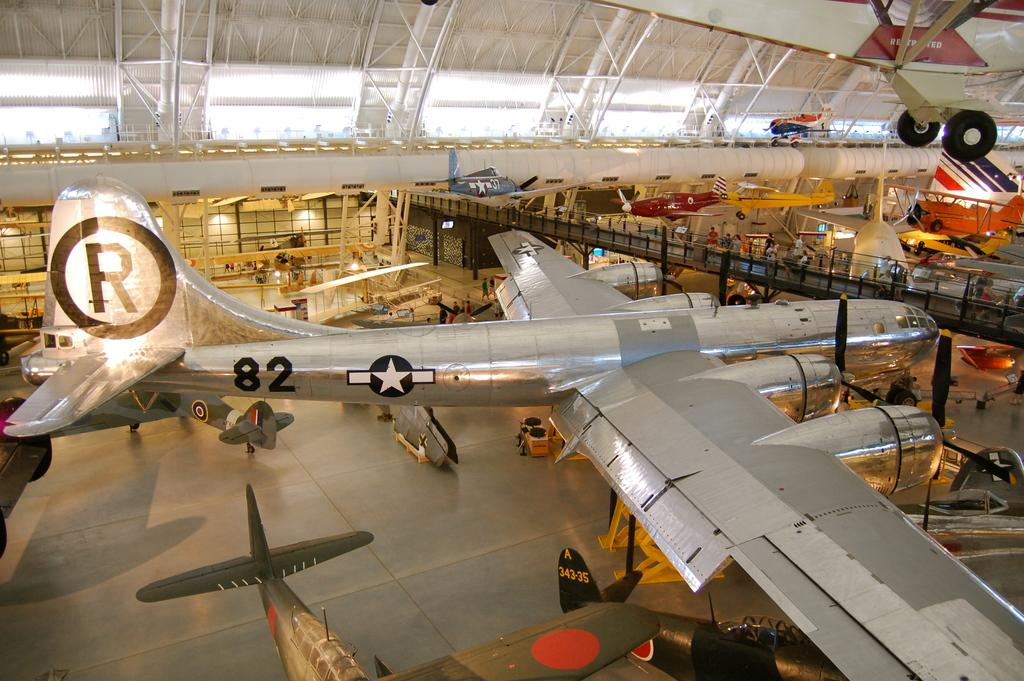<image>
Offer a succinct explanation of the picture presented. a silver airplane with an R on the tail in a hangar 